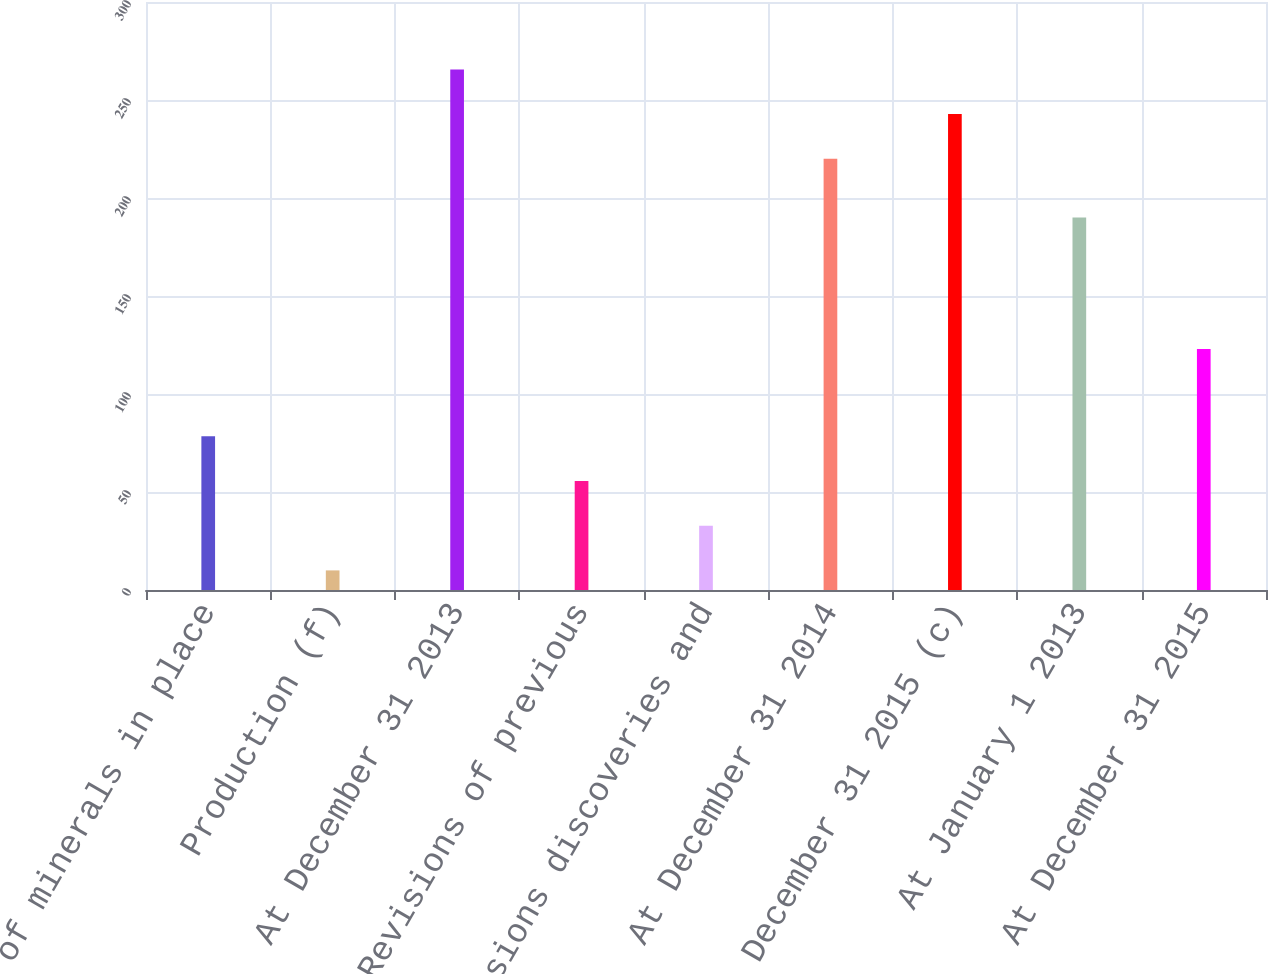<chart> <loc_0><loc_0><loc_500><loc_500><bar_chart><fcel>Sales of minerals in place<fcel>Production (f)<fcel>At December 31 2013<fcel>Revisions of previous<fcel>Extensions discoveries and<fcel>At December 31 2014<fcel>At December 31 2015 (c)<fcel>At January 1 2013<fcel>At December 31 2015<nl><fcel>78.4<fcel>10<fcel>265.6<fcel>55.6<fcel>32.8<fcel>220<fcel>242.8<fcel>190<fcel>123<nl></chart> 